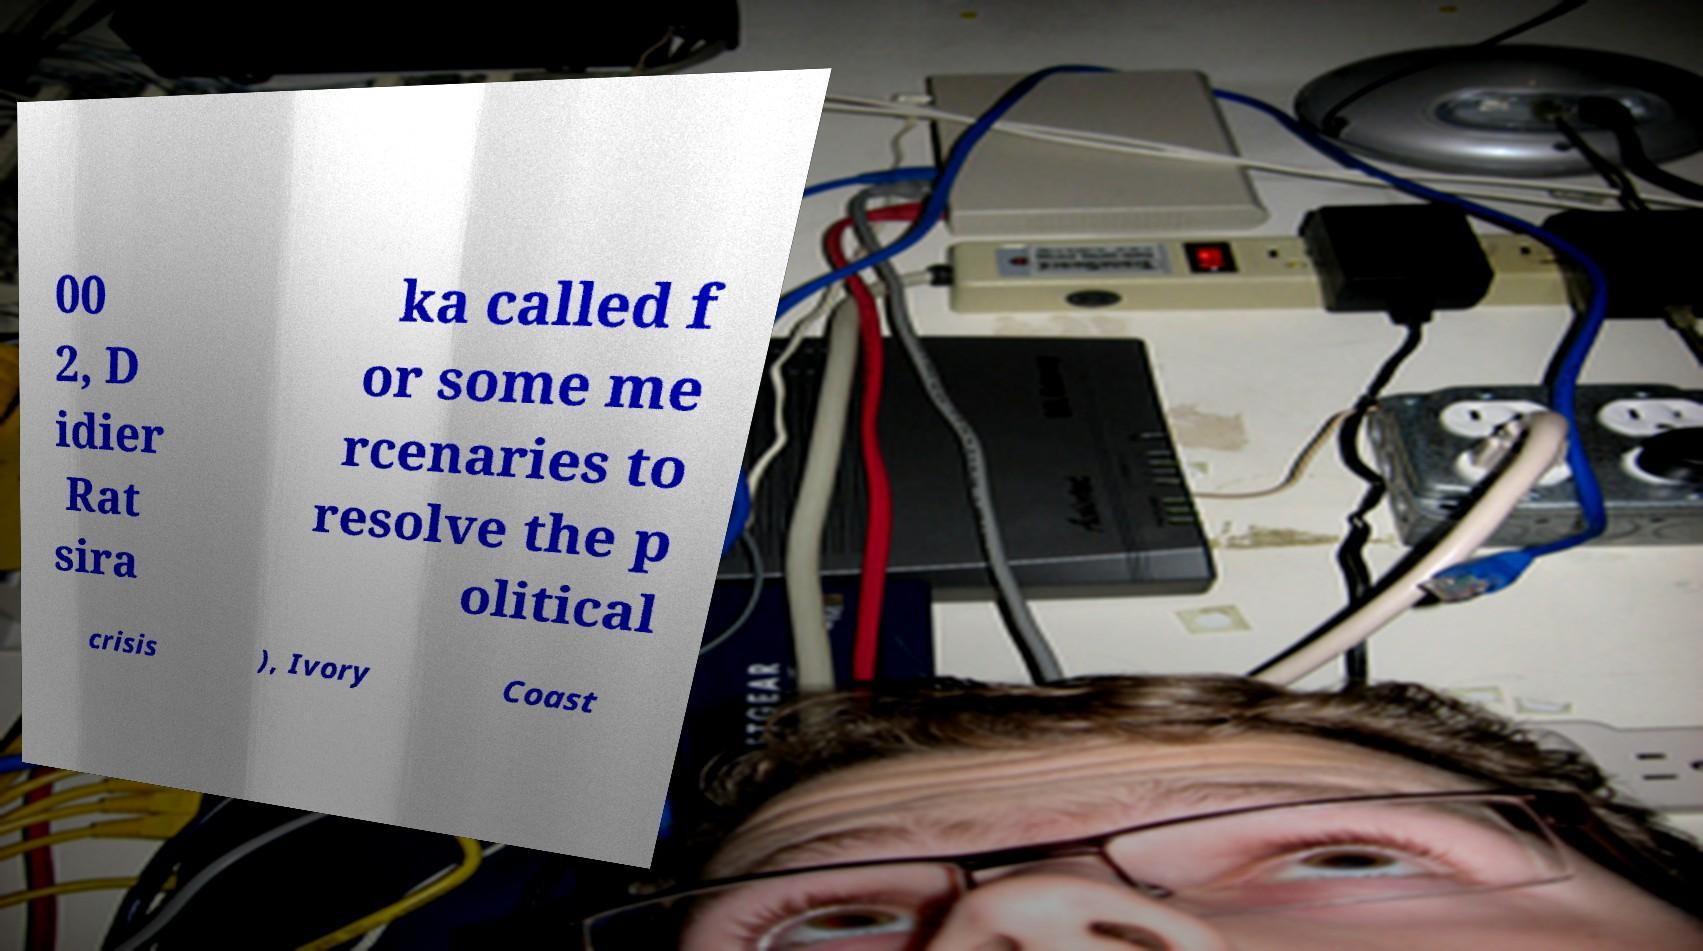Please identify and transcribe the text found in this image. 00 2, D idier Rat sira ka called f or some me rcenaries to resolve the p olitical crisis ), Ivory Coast 